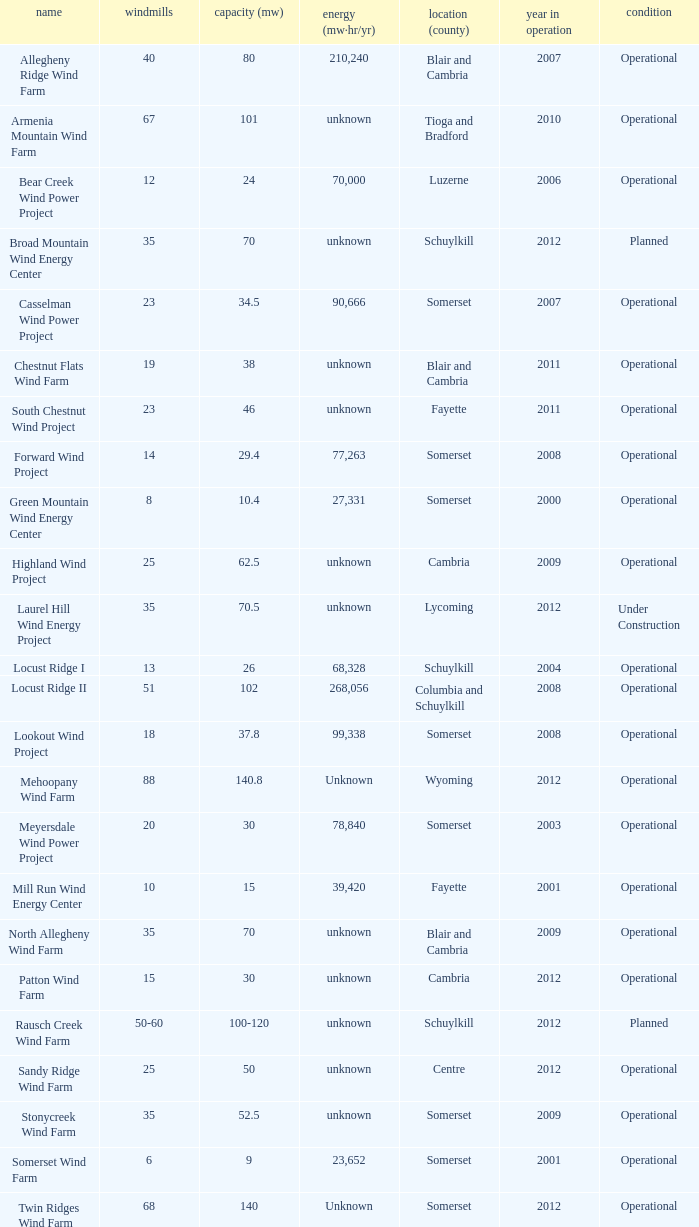What locations are considered centre? Unknown. 